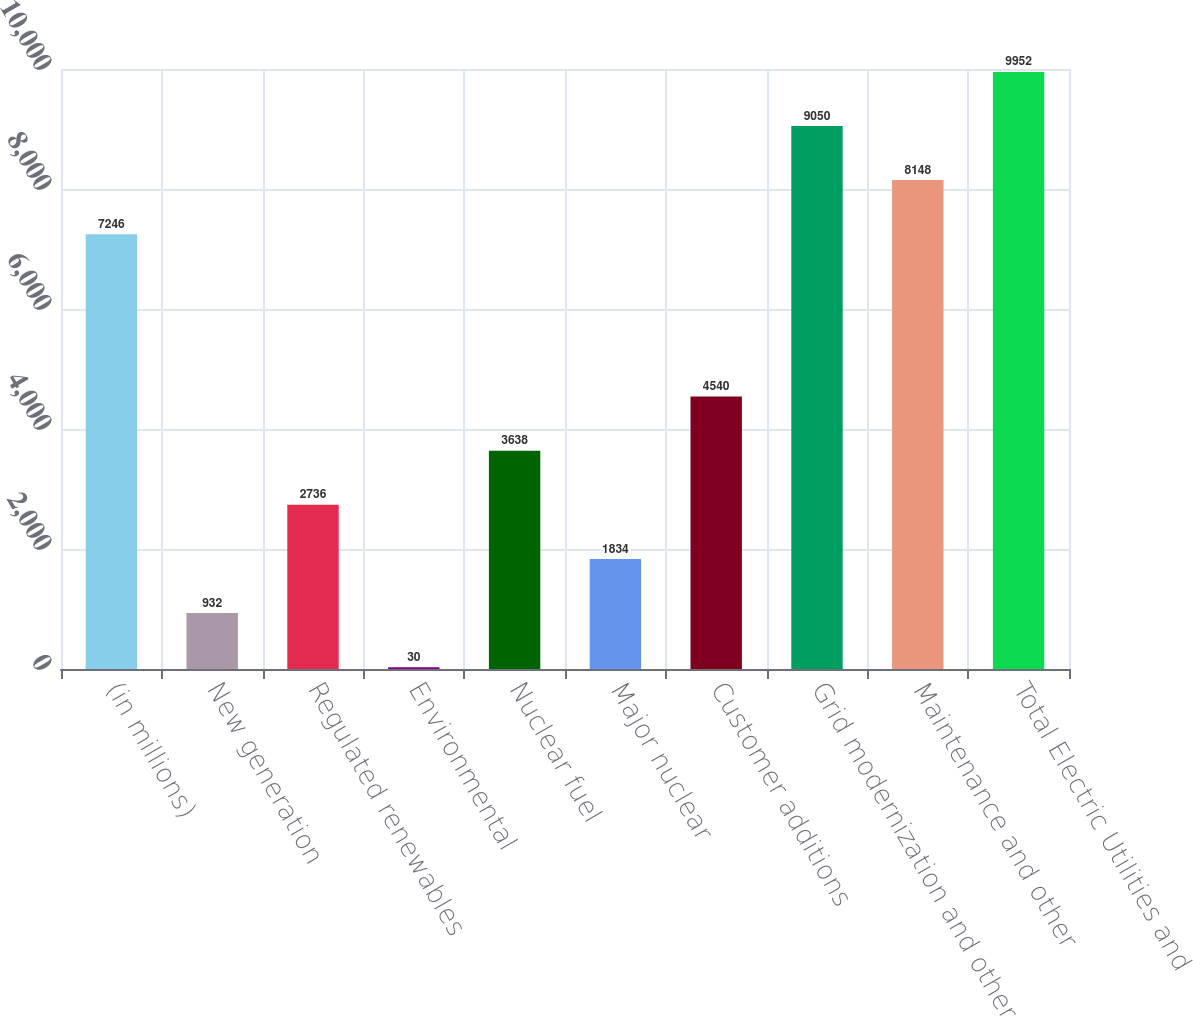Convert chart to OTSL. <chart><loc_0><loc_0><loc_500><loc_500><bar_chart><fcel>(in millions)<fcel>New generation<fcel>Regulated renewables<fcel>Environmental<fcel>Nuclear fuel<fcel>Major nuclear<fcel>Customer additions<fcel>Grid modernization and other<fcel>Maintenance and other<fcel>Total Electric Utilities and<nl><fcel>7246<fcel>932<fcel>2736<fcel>30<fcel>3638<fcel>1834<fcel>4540<fcel>9050<fcel>8148<fcel>9952<nl></chart> 